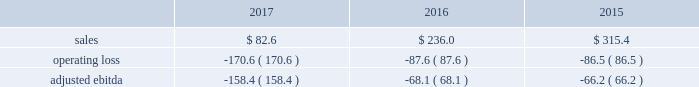2016 vs .
2015 sales of $ 498.8 increased $ 212.1 , or 74% ( 74 % ) .
The increase in sales was driven by the jazan project which more than offset the decrease in small equipment and other air separation unit sales .
In 2016 , we recognized approximately $ 300 of sales related to the jazan project .
Operating loss of $ 21.3 decreased 59% ( 59 % ) , or $ 30.3 , primarily from income on the jazan project and benefits from cost reduction actions , partially offset by lower other sale of equipment project activity and a gain associated with the cancellation of a sale of equipment contract that was recorded in fiscal year 2015 .
Corporate and other the corporate and other segment includes two ongoing global businesses ( our lng equipment business and our liquid helium and liquid hydrogen transport and storage container businesses ) , and corporate support functions that benefit all the segments .
Corporate and other also includes income and expense that is not directly associated with the business segments , including foreign exchange gains and losses and stranded costs .
Stranded costs result from functional support previously provided to the two divisions comprising the former materials technologies segment .
The majority of these costs are reimbursed to air products pursuant to short-term transition services agreements under which air products provides transition services to versum for emd and to evonik for pmd .
The reimbursement for costs in support of the transition services has been reflected on the consolidated income statements within "other income ( expense ) , net." .
2017 vs .
2016 sales of $ 82.6 decreased $ 153.4 , primarily due to lower lng project activity .
We expect continued weakness in new lng project orders due to continued oversupply of lng in the market .
Operating loss of $ 170.6 increased $ 83.0 due to lower lng activity , partially offset by productivity improvements and income from transition service agreements with versum and evonik .
2016 vs .
2015 sales of $ 236.0 decreased $ 79.4 , or 25% ( 25 % ) , primarily due to lower lng sale of equipment activity .
Operating loss of $ 87.6 increased 1% ( 1 % ) , or $ 1.1 , due to lower lng activity , mostly offset by benefits from our recent cost reduction actions and lower foreign exchange losses .
Reconciliation of non-gaap financial measures ( millions of dollars unless otherwise indicated , except for per share data ) the company has presented certain financial measures on a non-gaap ( 201cadjusted 201d ) basis and has provided a reconciliation to the most directly comparable financial measure calculated in accordance with gaap .
These financial measures are not meant to be considered in isolation or as a substitute for the most directly comparable financial measure calculated in accordance with gaap .
The company believes these non-gaap measures provide investors , potential investors , securities analysts , and others with useful supplemental information to evaluate the performance of the business because such measures , when viewed together with our financial results computed in accordance with gaap , provide a more complete understanding of the factors and trends affecting our historical financial performance and projected future results .
In many cases , our non-gaap measures are determined by adjusting the most directly comparable gaap financial measure to exclude certain disclosed items ( 201cnon-gaap adjustments 201d ) that we believe are not representative of the underlying business performance .
For example , air products has executed its strategic plan to restructure the company to focus on its core industrial gases business .
This resulted in significant cost reduction and asset actions that we believe are important for investors to understand separately from the performance of the underlying business .
The reader should be aware that we may incur similar expenses in the future .
The tax impact of our non- gaap adjustments reflects the expected current and deferred income tax expense impact of the transactions and is impacted primarily by the statutory tax rate of the various relevant jurisdictions and the taxability of the adjustments in those jurisdictions .
Investors should also consider the limitations associated with these non-gaap measures , including the potential lack of comparability of these measures from one company to another. .
Considering the years 2015-2017 , what is the average operating loss? 
Rationale: it is the sum of all operating loss divided by three ( the sum of the years ) .
Computations: table_average(operating loss, none)
Answer: -114.9. 